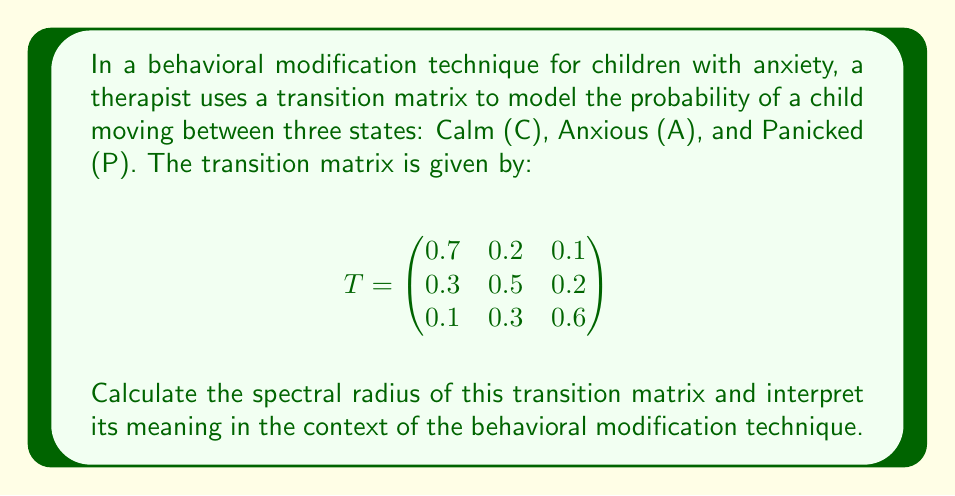Solve this math problem. To find the spectral radius of the transition matrix, we need to follow these steps:

1) First, we need to find the eigenvalues of the matrix. The characteristic equation is:

   $$det(T - \lambda I) = 0$$

   $$\begin{vmatrix}
   0.7 - \lambda & 0.2 & 0.1 \\
   0.3 & 0.5 - \lambda & 0.2 \\
   0.1 & 0.3 & 0.6 - \lambda
   \end{vmatrix} = 0$$

2) Expanding this determinant:

   $$(0.7 - \lambda)((0.5 - \lambda)(0.6 - \lambda) - 0.06) - 0.2(0.3(0.6 - \lambda) - 0.02) + 0.1(0.3(0.5 - \lambda) - 0.06) = 0$$

3) Simplifying:

   $$-\lambda^3 + 1.8\lambda^2 - 0.98\lambda + 0.16 = 0$$

4) This cubic equation can be solved using numerical methods. The eigenvalues are approximately:

   $$\lambda_1 \approx 1, \lambda_2 \approx 0.5, \lambda_3 \approx 0.3$$

5) The spectral radius is the largest absolute value of the eigenvalues:

   $$\rho(T) = \max(|\lambda_1|, |\lambda_2|, |\lambda_3|) = 1$$

6) Interpretation: In the context of behavioral modification, a spectral radius of 1 indicates that the child's state will converge to a stable distribution over time. This means that with repeated application of the technique, the child's anxiety levels will stabilize, rather than continuously improving or worsening.
Answer: $\rho(T) = 1$ 